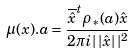<formula> <loc_0><loc_0><loc_500><loc_500>\mu ( x ) . a = \frac { \overline { \hat { x } } ^ { t } \rho _ { \ast } ( a ) \hat { x } } { 2 \pi i | \, | \hat { x } | \, | ^ { 2 } }</formula> 